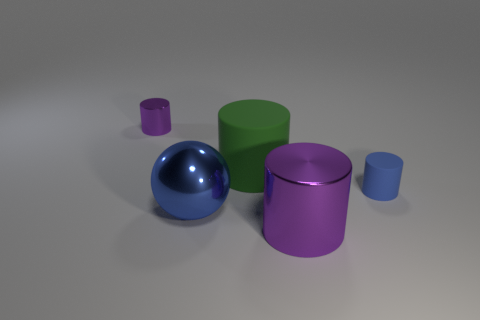What is the material of the object that is behind the blue matte cylinder and on the right side of the small metal cylinder?
Provide a succinct answer. Rubber. What number of things are either large gray shiny cubes or large objects?
Your answer should be compact. 3. Is the number of green matte things greater than the number of metal objects?
Provide a short and direct response. No. How big is the metal cylinder that is behind the small cylinder that is right of the small purple object?
Give a very brief answer. Small. There is a tiny metallic object that is the same shape as the blue matte object; what is its color?
Offer a very short reply. Purple. The blue matte thing has what size?
Ensure brevity in your answer.  Small. How many balls are purple things or blue matte objects?
Offer a terse response. 0. There is another rubber object that is the same shape as the green matte object; what size is it?
Offer a very short reply. Small. What number of purple cylinders are there?
Your answer should be compact. 2. There is a tiny metal thing; does it have the same shape as the rubber thing in front of the large green thing?
Offer a terse response. Yes. 